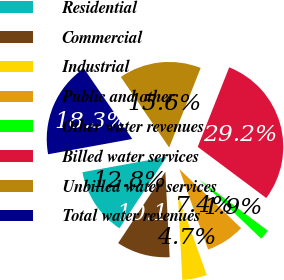Convert chart to OTSL. <chart><loc_0><loc_0><loc_500><loc_500><pie_chart><fcel>Residential<fcel>Commercial<fcel>Industrial<fcel>Public and other<fcel>Other water revenues<fcel>Billed water services<fcel>Unbilled water services<fcel>Total water revenues<nl><fcel>12.84%<fcel>10.11%<fcel>4.66%<fcel>7.39%<fcel>1.93%<fcel>29.21%<fcel>15.57%<fcel>18.3%<nl></chart> 